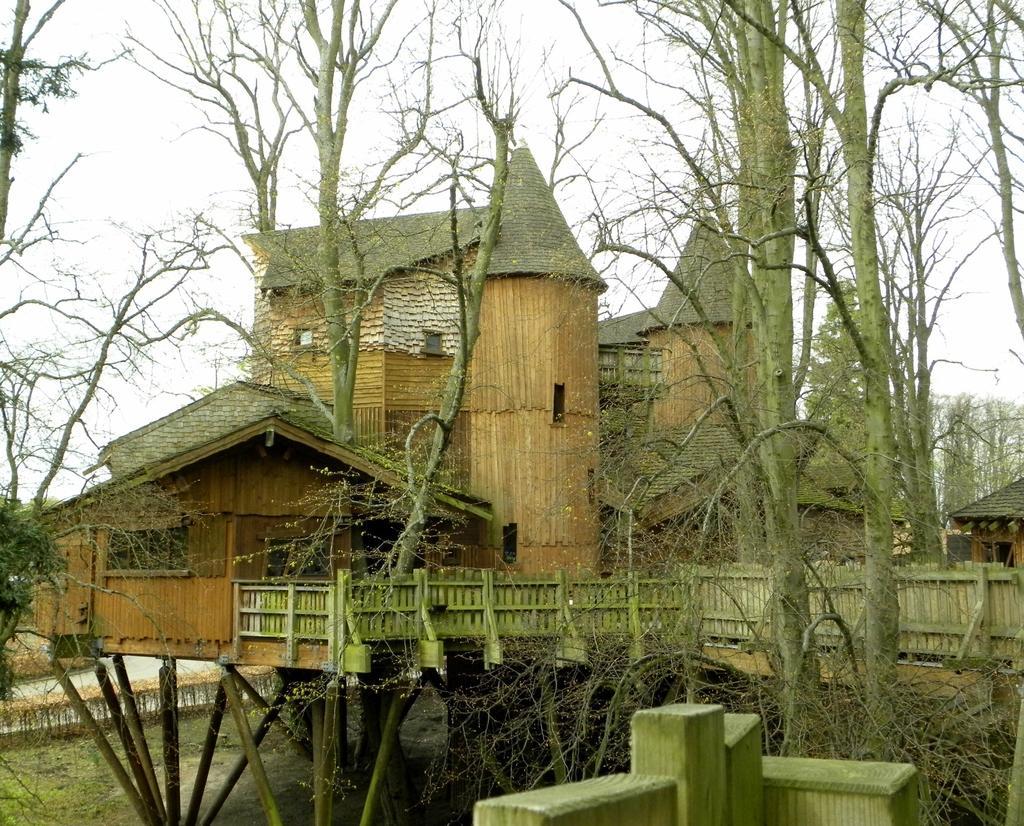In one or two sentences, can you explain what this image depicts? In this picture we can see an old house with wooden fencing and trees around it. 